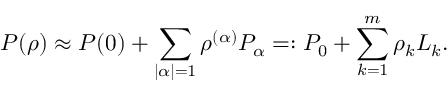Convert formula to latex. <formula><loc_0><loc_0><loc_500><loc_500>P ( \rho ) \approx P ( 0 ) + \sum _ { | \alpha | = 1 } \rho ^ { ( \alpha ) } P _ { \alpha } = \colon P _ { 0 } + \sum _ { k = 1 } ^ { m } \rho _ { k } L _ { k } .</formula> 